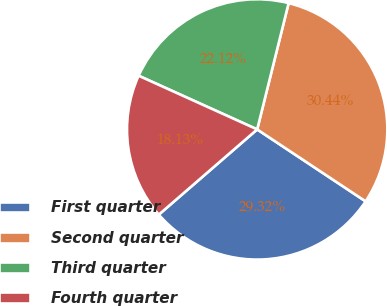Convert chart to OTSL. <chart><loc_0><loc_0><loc_500><loc_500><pie_chart><fcel>First quarter<fcel>Second quarter<fcel>Third quarter<fcel>Fourth quarter<nl><fcel>29.32%<fcel>30.44%<fcel>22.12%<fcel>18.13%<nl></chart> 